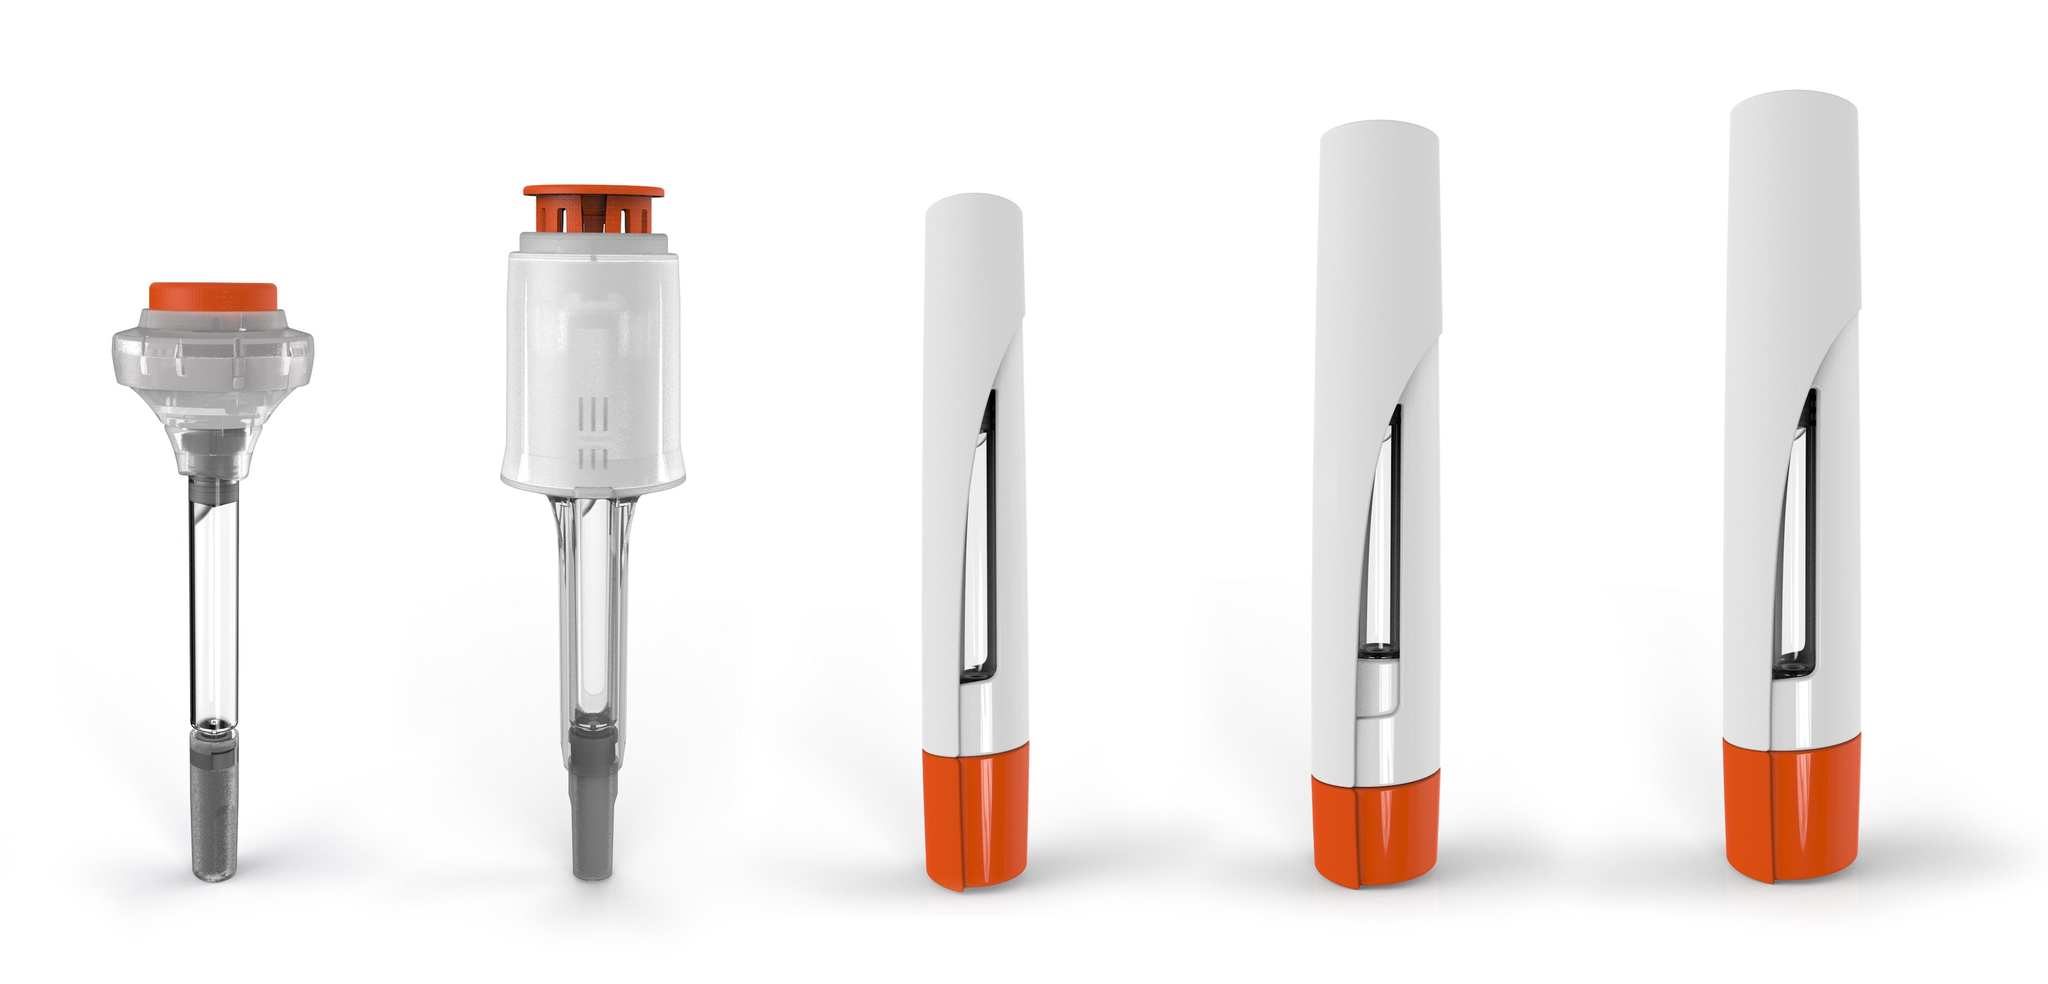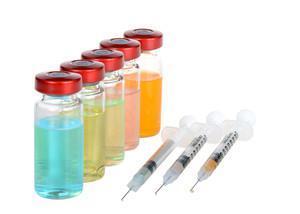The first image is the image on the left, the second image is the image on the right. Examine the images to the left and right. Is the description "An image includes exactly three syringes displayed side-by-side at the same diagonal angle." accurate? Answer yes or no. Yes. The first image is the image on the left, the second image is the image on the right. Analyze the images presented: Is the assertion "The syringe in the right image furthest to the right has a red substance inside it." valid? Answer yes or no. No. 